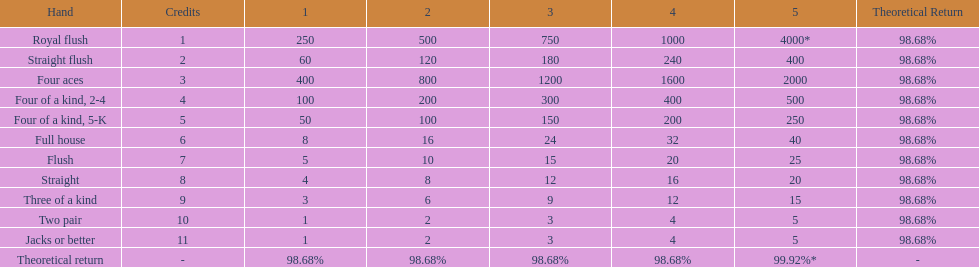Is a 2 credit full house the same as a 5 credit three of a kind? No. 